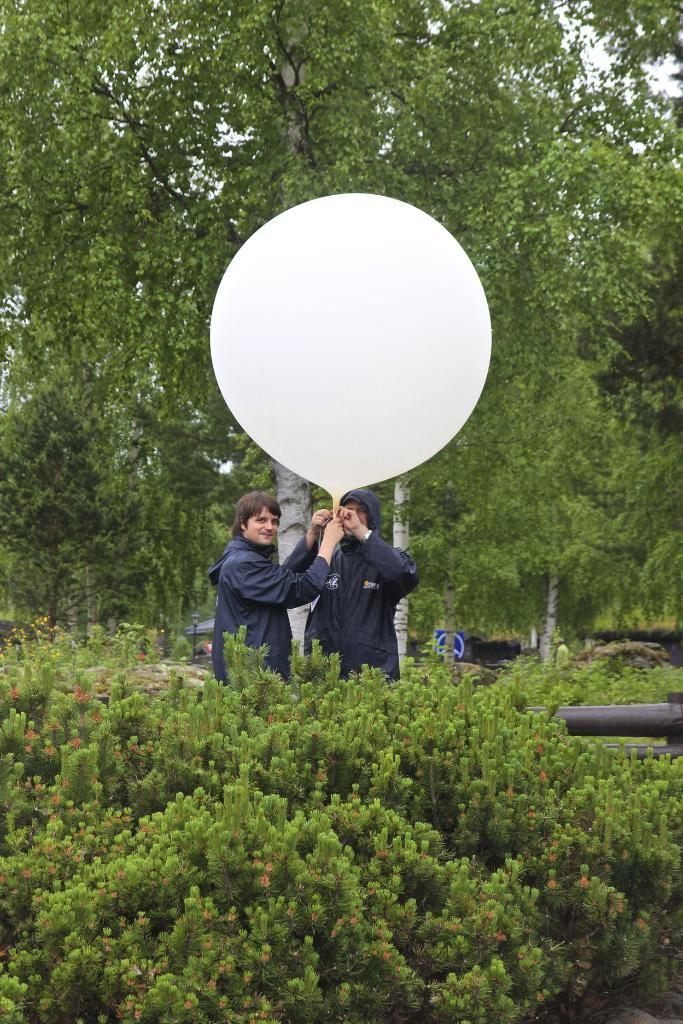How many people are in the image? There are two persons in the image. What are the two persons holding? The two persons are holding a balloon. What else can be seen in the image besides the people and the balloon? There are plants, a pole, a light, trees, and the sky visible in the image. What type of vegetable is being crushed by the pole in the image? There is no vegetable being crushed by the pole in the image. Is there a jail visible in the image? No, there is no jail present in the image. 